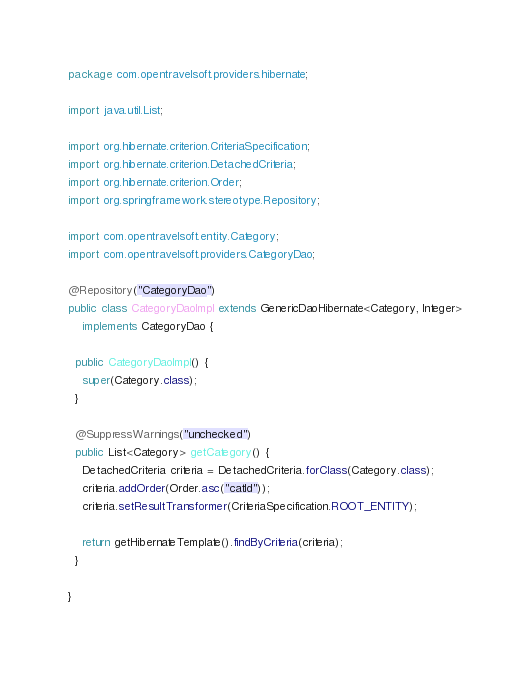Convert code to text. <code><loc_0><loc_0><loc_500><loc_500><_Java_>package com.opentravelsoft.providers.hibernate;

import java.util.List;

import org.hibernate.criterion.CriteriaSpecification;
import org.hibernate.criterion.DetachedCriteria;
import org.hibernate.criterion.Order;
import org.springframework.stereotype.Repository;

import com.opentravelsoft.entity.Category;
import com.opentravelsoft.providers.CategoryDao;

@Repository("CategoryDao")
public class CategoryDaoImpl extends GenericDaoHibernate<Category, Integer>
    implements CategoryDao {

  public CategoryDaoImpl() {
    super(Category.class);
  }

  @SuppressWarnings("unchecked")
  public List<Category> getCategory() {
    DetachedCriteria criteria = DetachedCriteria.forClass(Category.class);
    criteria.addOrder(Order.asc("catId"));
    criteria.setResultTransformer(CriteriaSpecification.ROOT_ENTITY);

    return getHibernateTemplate().findByCriteria(criteria);
  }

}
</code> 